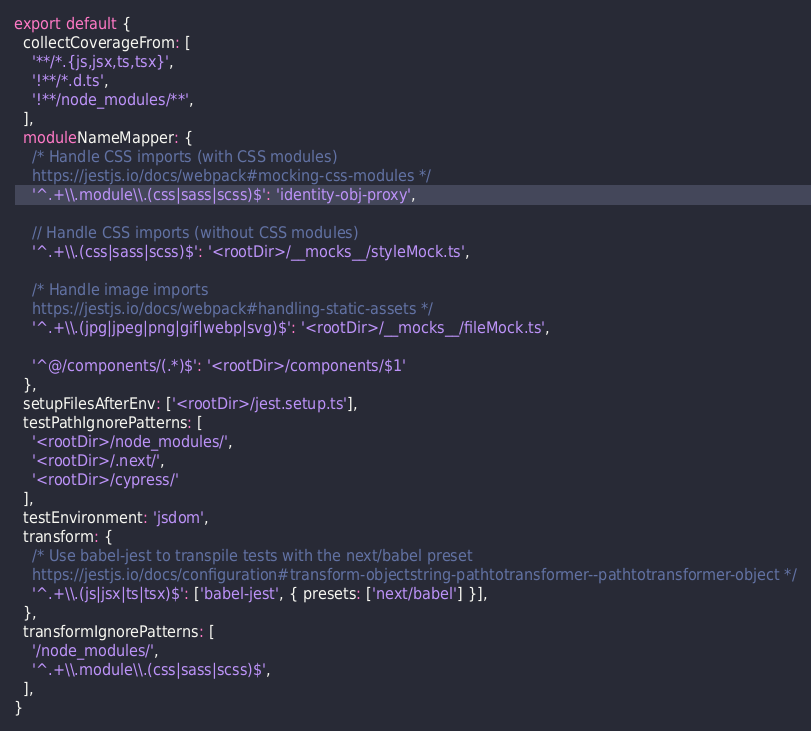Convert code to text. <code><loc_0><loc_0><loc_500><loc_500><_TypeScript_>export default {
  collectCoverageFrom: [
    '**/*.{js,jsx,ts,tsx}',
    '!**/*.d.ts',
    '!**/node_modules/**',
  ],
  moduleNameMapper: {
    /* Handle CSS imports (with CSS modules)
    https://jestjs.io/docs/webpack#mocking-css-modules */
    '^.+\\.module\\.(css|sass|scss)$': 'identity-obj-proxy',

    // Handle CSS imports (without CSS modules)
    '^.+\\.(css|sass|scss)$': '<rootDir>/__mocks__/styleMock.ts',

    /* Handle image imports
    https://jestjs.io/docs/webpack#handling-static-assets */
    '^.+\\.(jpg|jpeg|png|gif|webp|svg)$': '<rootDir>/__mocks__/fileMock.ts',

    '^@/components/(.*)$': '<rootDir>/components/$1'
  },
  setupFilesAfterEnv: ['<rootDir>/jest.setup.ts'],
  testPathIgnorePatterns: [
    '<rootDir>/node_modules/',
    '<rootDir>/.next/',
    '<rootDir>/cypress/'
  ],
  testEnvironment: 'jsdom',
  transform: {
    /* Use babel-jest to transpile tests with the next/babel preset
    https://jestjs.io/docs/configuration#transform-objectstring-pathtotransformer--pathtotransformer-object */
    '^.+\\.(js|jsx|ts|tsx)$': ['babel-jest', { presets: ['next/babel'] }],
  },
  transformIgnorePatterns: [
    '/node_modules/',
    '^.+\\.module\\.(css|sass|scss)$',
  ],
}</code> 